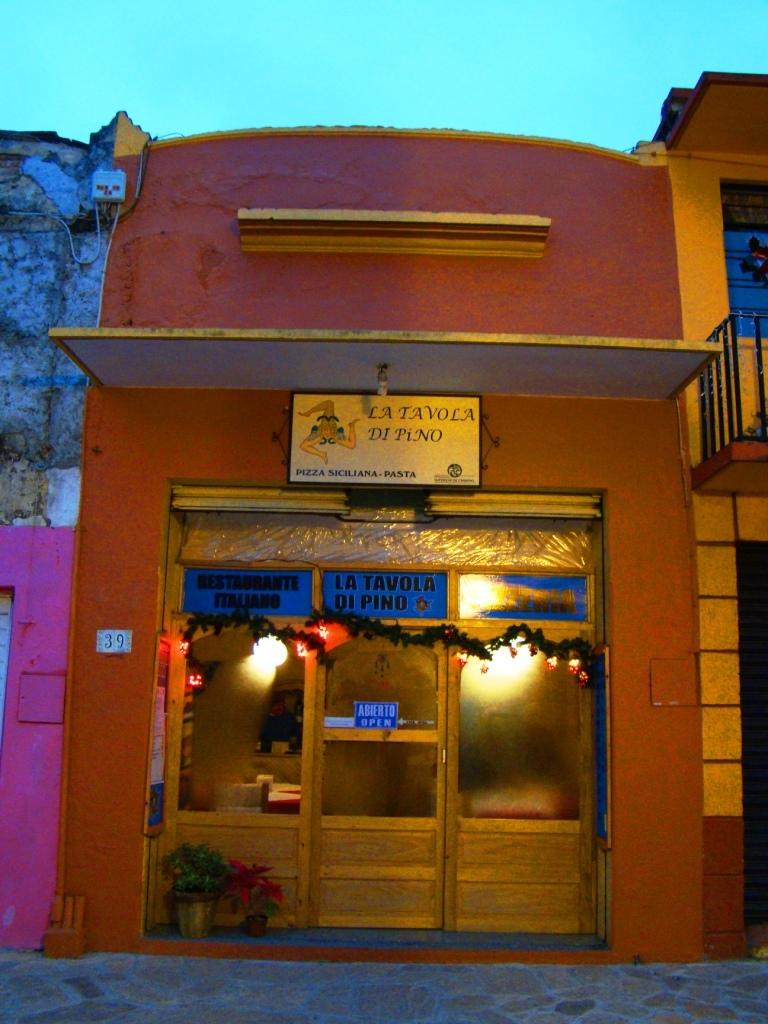What type of structure is in the image? There is a building in the image. What is located in front of the building? There is an entrance gate in front of the building. What decorative elements are present near the entrance gate? Flower pots and plants are present in front of the entrance gate. What feature of the building is visible in the image? Lights are visible on the building. What type of mountain range can be seen in the background of the image? There is no mountain range visible in the image; it features a building, entrance gate, flower pots, plants, and lights. Is there a notebook on the building in the image? There is no notebook present in the image. 